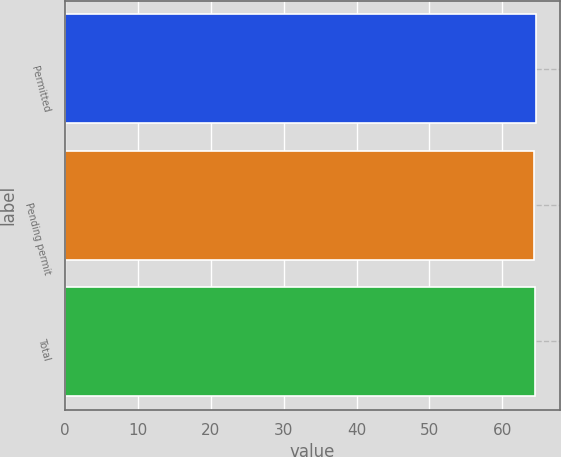Convert chart. <chart><loc_0><loc_0><loc_500><loc_500><bar_chart><fcel>Permitted<fcel>Pending permit<fcel>Total<nl><fcel>64.61<fcel>64.34<fcel>64.51<nl></chart> 